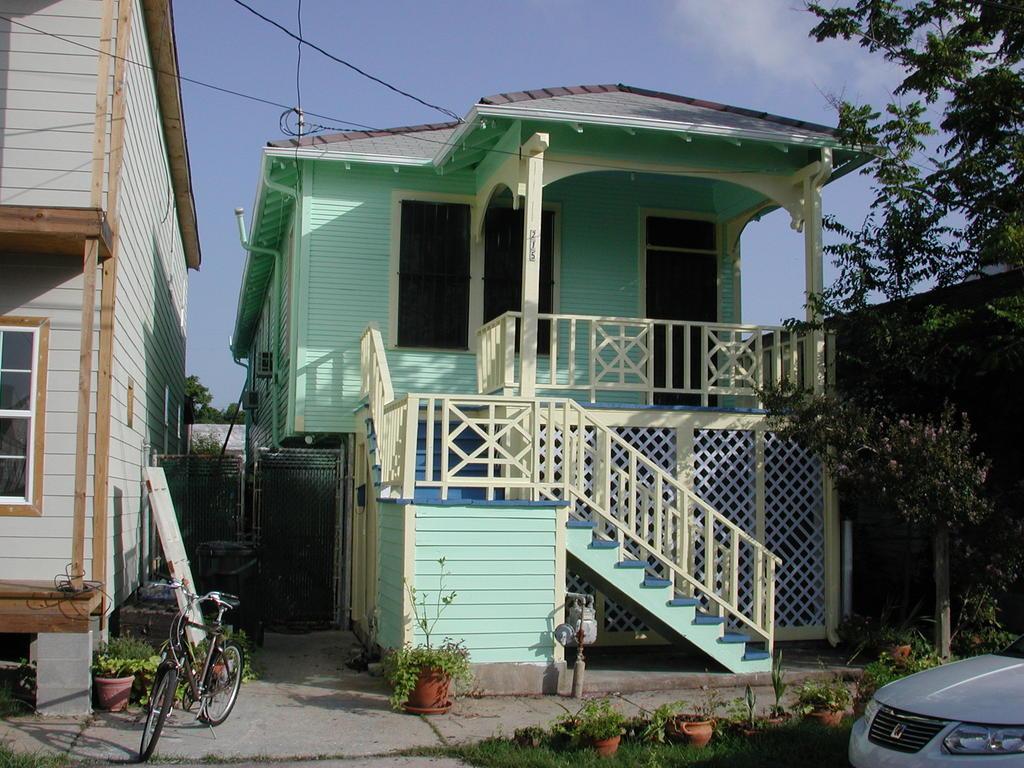Describe this image in one or two sentences. This image consists of houses. It looks like they are made up of wood. At the bottom, we can see potted plants and green plants on the ground. In the middle, there is a cycle. On the right, there is a car along with the trees. At the top, there is the sky. 